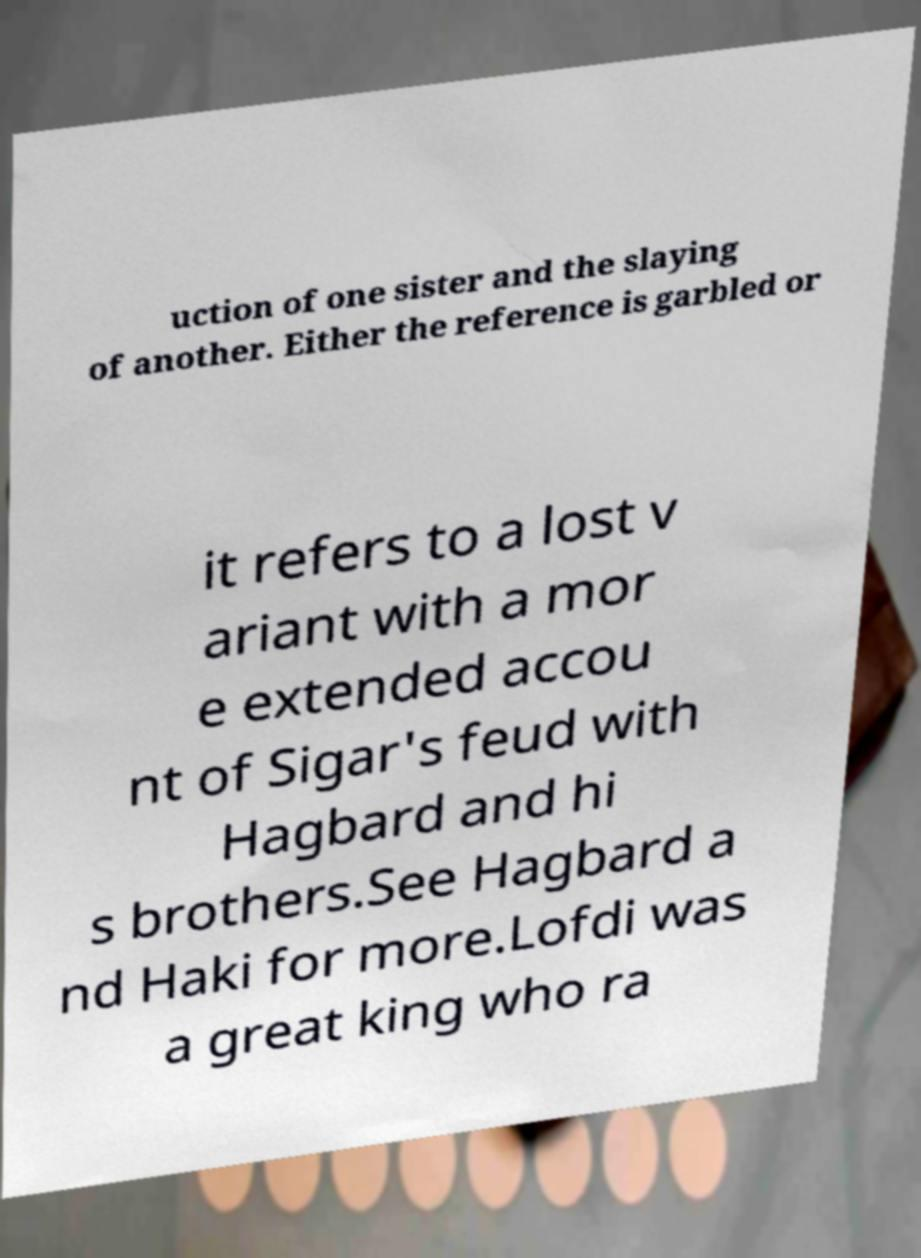What messages or text are displayed in this image? I need them in a readable, typed format. uction of one sister and the slaying of another. Either the reference is garbled or it refers to a lost v ariant with a mor e extended accou nt of Sigar's feud with Hagbard and hi s brothers.See Hagbard a nd Haki for more.Lofdi was a great king who ra 